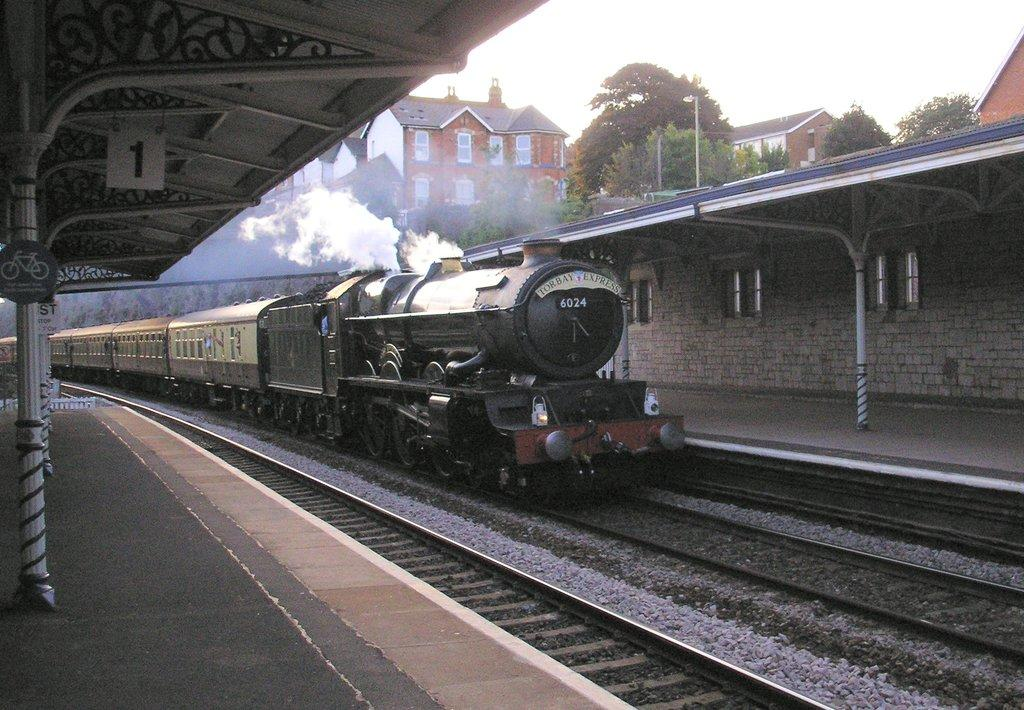What is the main subject of the image? The main subject of the image is a train. Where is the train located in the image? The train is on a track. What else can be seen in the image besides the train? There is a platform, buildings, trees, and the sky visible in the background of the image. What type of arch can be seen supporting the train in the image? There is no arch present in the image; the train is on a track. How does the train show respect to the passengers in the image? The train does not show respect in the image; it is an inanimate object. 